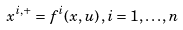<formula> <loc_0><loc_0><loc_500><loc_500>x ^ { i , + } = f ^ { i } ( x , u ) \, , i = 1 , \dots , n</formula> 